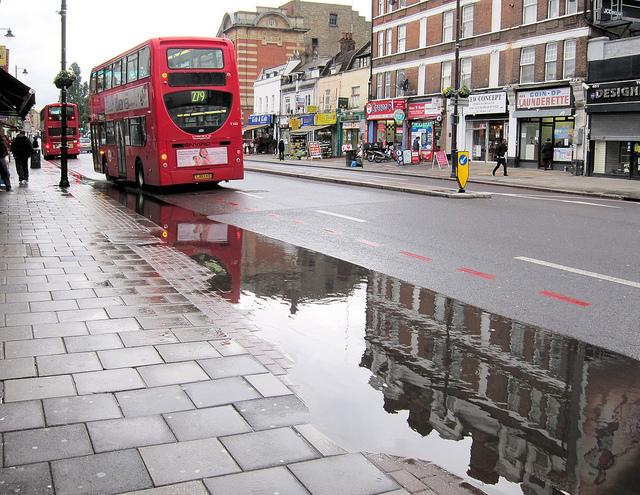If you wanted to wash clothes near here what would you need?

Choices:
A) credit cards
B) nothing
C) dollar bills
D) coins coins 